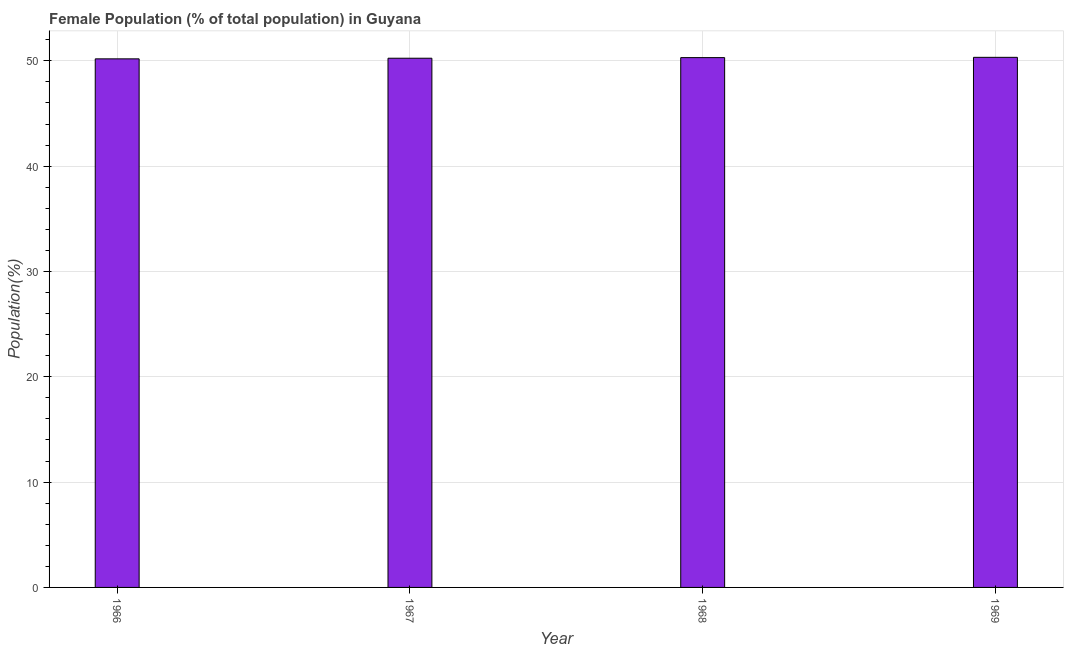Does the graph contain any zero values?
Provide a short and direct response. No. Does the graph contain grids?
Keep it short and to the point. Yes. What is the title of the graph?
Make the answer very short. Female Population (% of total population) in Guyana. What is the label or title of the Y-axis?
Provide a short and direct response. Population(%). What is the female population in 1969?
Offer a very short reply. 50.33. Across all years, what is the maximum female population?
Offer a very short reply. 50.33. Across all years, what is the minimum female population?
Give a very brief answer. 50.19. In which year was the female population maximum?
Ensure brevity in your answer.  1969. In which year was the female population minimum?
Your response must be concise. 1966. What is the sum of the female population?
Your answer should be compact. 201.08. What is the difference between the female population in 1966 and 1969?
Give a very brief answer. -0.14. What is the average female population per year?
Provide a succinct answer. 50.27. What is the median female population?
Your answer should be compact. 50.28. In how many years, is the female population greater than 46 %?
Provide a short and direct response. 4. Do a majority of the years between 1966 and 1968 (inclusive) have female population greater than 12 %?
Provide a succinct answer. Yes. Is the female population in 1967 less than that in 1968?
Provide a succinct answer. Yes. What is the difference between the highest and the second highest female population?
Your answer should be compact. 0.03. Is the sum of the female population in 1968 and 1969 greater than the maximum female population across all years?
Provide a succinct answer. Yes. What is the difference between the highest and the lowest female population?
Offer a very short reply. 0.14. In how many years, is the female population greater than the average female population taken over all years?
Make the answer very short. 2. How many bars are there?
Keep it short and to the point. 4. How many years are there in the graph?
Offer a very short reply. 4. Are the values on the major ticks of Y-axis written in scientific E-notation?
Give a very brief answer. No. What is the Population(%) in 1966?
Your answer should be very brief. 50.19. What is the Population(%) in 1967?
Your answer should be very brief. 50.25. What is the Population(%) of 1968?
Ensure brevity in your answer.  50.31. What is the Population(%) in 1969?
Your response must be concise. 50.33. What is the difference between the Population(%) in 1966 and 1967?
Provide a short and direct response. -0.06. What is the difference between the Population(%) in 1966 and 1968?
Provide a short and direct response. -0.12. What is the difference between the Population(%) in 1966 and 1969?
Your response must be concise. -0.14. What is the difference between the Population(%) in 1967 and 1968?
Ensure brevity in your answer.  -0.06. What is the difference between the Population(%) in 1967 and 1969?
Give a very brief answer. -0.08. What is the difference between the Population(%) in 1968 and 1969?
Give a very brief answer. -0.03. What is the ratio of the Population(%) in 1967 to that in 1968?
Provide a short and direct response. 1. What is the ratio of the Population(%) in 1967 to that in 1969?
Make the answer very short. 1. 